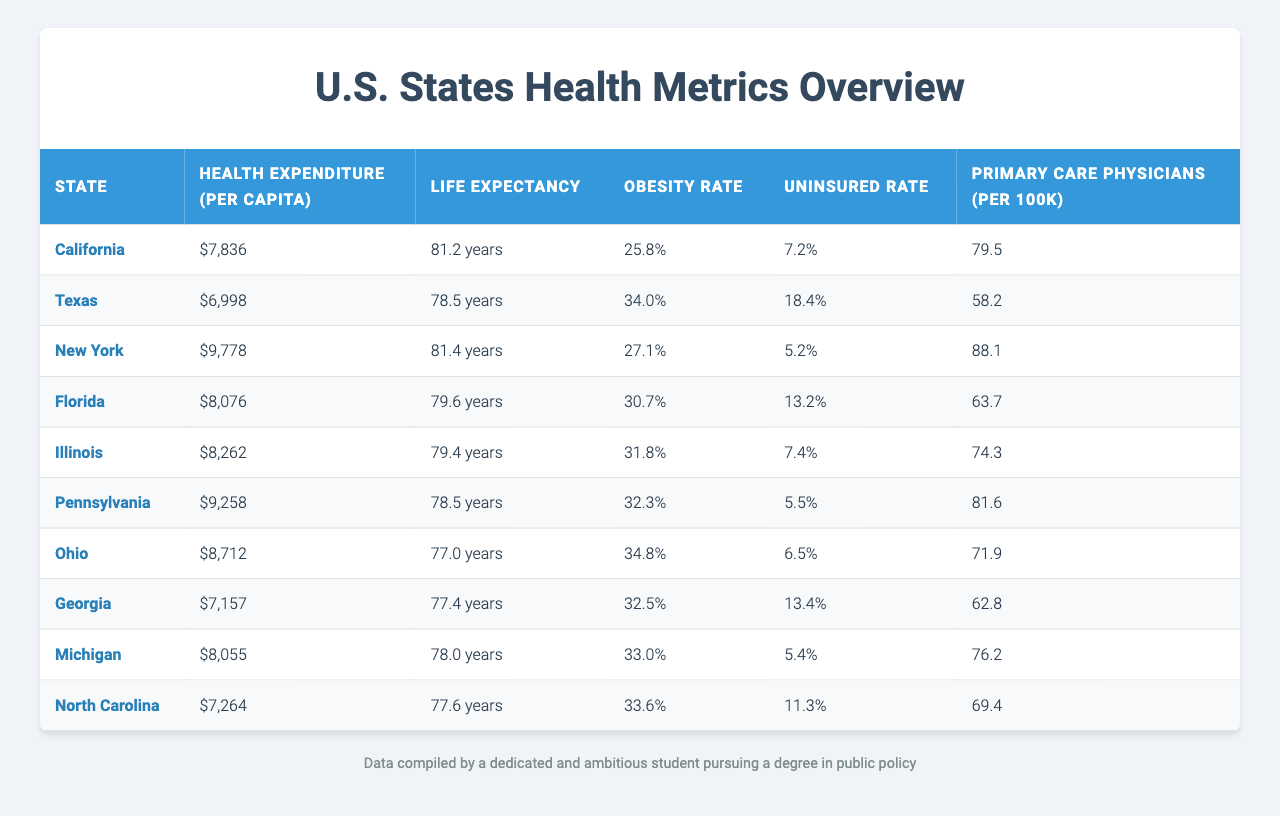What is the health expenditure per capita in California? The table shows that the health expenditure per capita for California is listed as $7,836.
Answer: $7,836 Which state has the highest life expectancy? By examining the life expectancy values, New York has the highest life expectancy at 81.4 years.
Answer: New York What percentage of the population is uninsured in Texas? The table indicates that the uninsured rate in Texas is 18.4%.
Answer: 18.4% Which state has the lowest obesity rate? Scanning through the obesity rates, California has the lowest rate at 25.8%.
Answer: California What is the average life expectancy of the states listed? To find the average life expectancy, we add the values (81.2 + 78.5 + 81.4 + 79.6 + 79.4 + 78.5 + 77.0 + 77.4 + 78.0 + 77.6) = 790.4, and then divide by the number of states (10). Thus, the average is 790.4 / 10 = 79.04 years.
Answer: 79.04 years Does higher health expenditure correlate with lower obesity rates based on this data? To determine this, we examine states with higher expenditures like California and New York, which have obesity rates of 25.8% and 27.1%, respectively. In contrast, Texas, which has a lower expenditure of $6,998, shows an obesity rate of 34.0%. This suggests a potential negative correlation between the two for these states.
Answer: Yes What is the total health expenditure per capita of the top three states? Adding the health expenditures of California ($7,836), New York ($9,778), and Illinois ($8,262), we get 7,836 + 9,778 + 8,262 = 25,876.
Answer: $25,876 Which state has the most primary care physicians per 100k population? Looking at the table, New York has the highest reported number of primary care physicians at 88.1 per 100k population.
Answer: New York Are there any states with an uninsured rate higher than 15%? Checking the table, Texas (18.4%) and Georgia (13.4%) both exceed 15%. Therefore, there are states with uninsured rates higher than 15%.
Answer: Yes What is the difference in life expectancy between California and Ohio? California's life expectancy is 81.2 years and Ohio's is 77.0 years. The difference is 81.2 - 77.0 = 4.2 years.
Answer: 4.2 years In which state is the relationship between health expenditure per capita and life expectancy not as straightforward? Observing states with high health expenditure such as Texas ($6,998) and relatively low life expectancy (78.5 years) suggests that there is not always a direct correlation. Thus, Texas presents a case where higher expenditure does not correspond with expected life expectancy.
Answer: Texas 